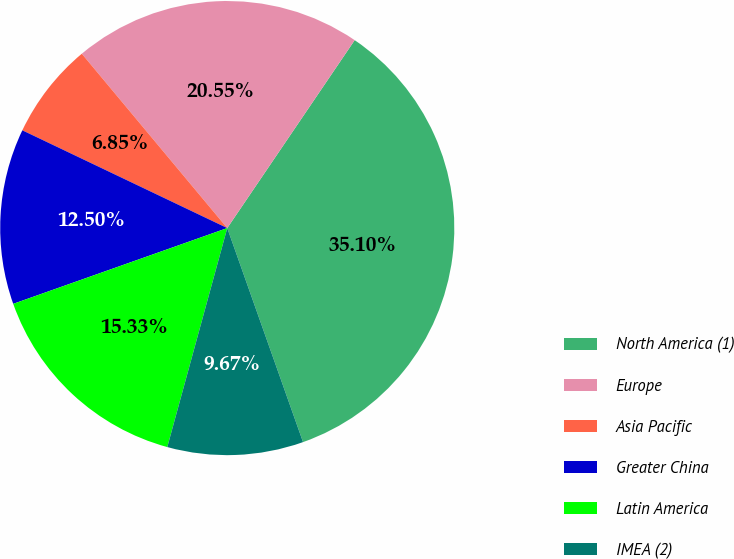<chart> <loc_0><loc_0><loc_500><loc_500><pie_chart><fcel>North America (1)<fcel>Europe<fcel>Asia Pacific<fcel>Greater China<fcel>Latin America<fcel>IMEA (2)<nl><fcel>35.1%<fcel>20.55%<fcel>6.85%<fcel>12.5%<fcel>15.33%<fcel>9.67%<nl></chart> 